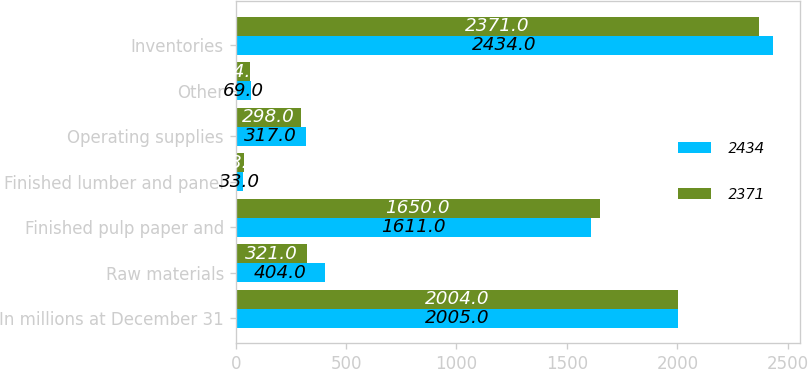<chart> <loc_0><loc_0><loc_500><loc_500><stacked_bar_chart><ecel><fcel>In millions at December 31<fcel>Raw materials<fcel>Finished pulp paper and<fcel>Finished lumber and panel<fcel>Operating supplies<fcel>Other<fcel>Inventories<nl><fcel>2434<fcel>2005<fcel>404<fcel>1611<fcel>33<fcel>317<fcel>69<fcel>2434<nl><fcel>2371<fcel>2004<fcel>321<fcel>1650<fcel>38<fcel>298<fcel>64<fcel>2371<nl></chart> 